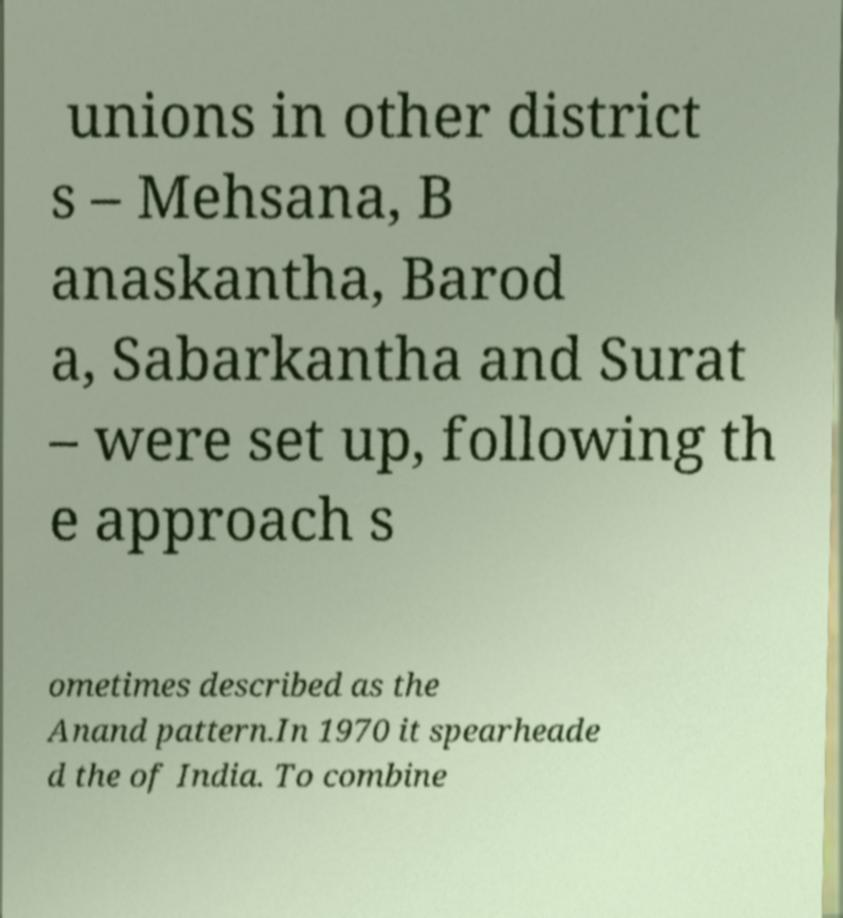Please read and relay the text visible in this image. What does it say? unions in other district s – Mehsana, B anaskantha, Barod a, Sabarkantha and Surat – were set up, following th e approach s ometimes described as the Anand pattern.In 1970 it spearheade d the of India. To combine 